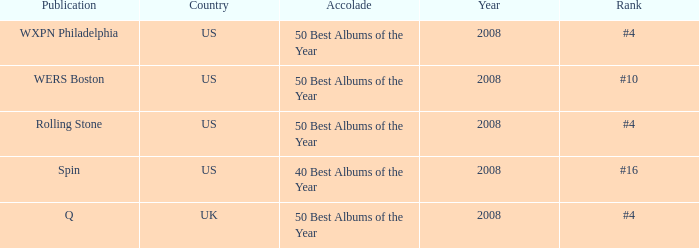Which publication happened in the UK? Q. 